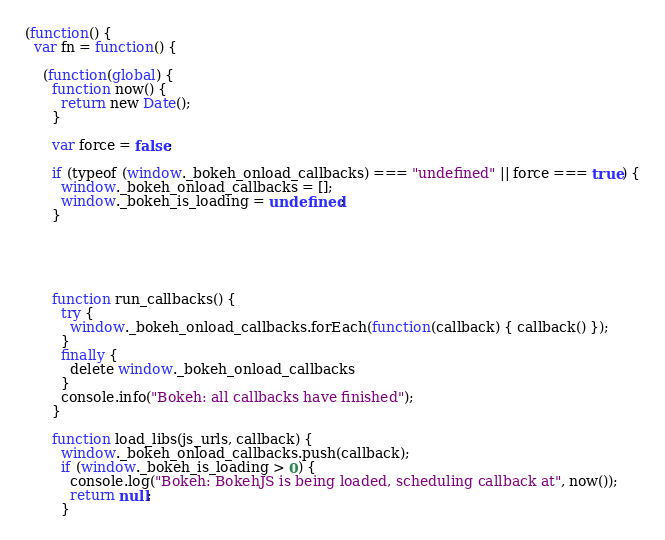Convert code to text. <code><loc_0><loc_0><loc_500><loc_500><_JavaScript_>(function() {
  var fn = function() {
    
    (function(global) {
      function now() {
        return new Date();
      }
    
      var force = false;
    
      if (typeof (window._bokeh_onload_callbacks) === "undefined" || force === true) {
        window._bokeh_onload_callbacks = [];
        window._bokeh_is_loading = undefined;
      }
    
    
      
      
    
      function run_callbacks() {
        try {
          window._bokeh_onload_callbacks.forEach(function(callback) { callback() });
        }
        finally {
          delete window._bokeh_onload_callbacks
        }
        console.info("Bokeh: all callbacks have finished");
      }
    
      function load_libs(js_urls, callback) {
        window._bokeh_onload_callbacks.push(callback);
        if (window._bokeh_is_loading > 0) {
          console.log("Bokeh: BokehJS is being loaded, scheduling callback at", now());
          return null;
        }</code> 